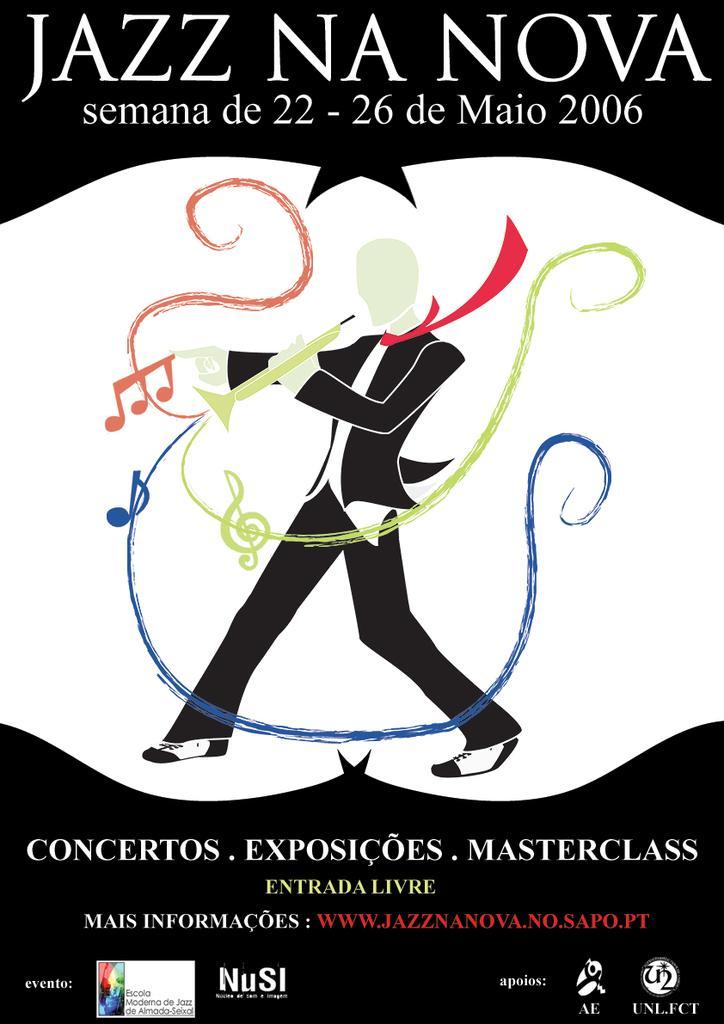Can you describe this image briefly? In this image there is a poster with a picture and text on it. 